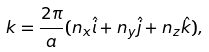<formula> <loc_0><loc_0><loc_500><loc_500>k = \frac { 2 \pi } { a } ( n _ { x } \hat { i } + n _ { y } \hat { j } + n _ { z } \hat { k } ) ,</formula> 